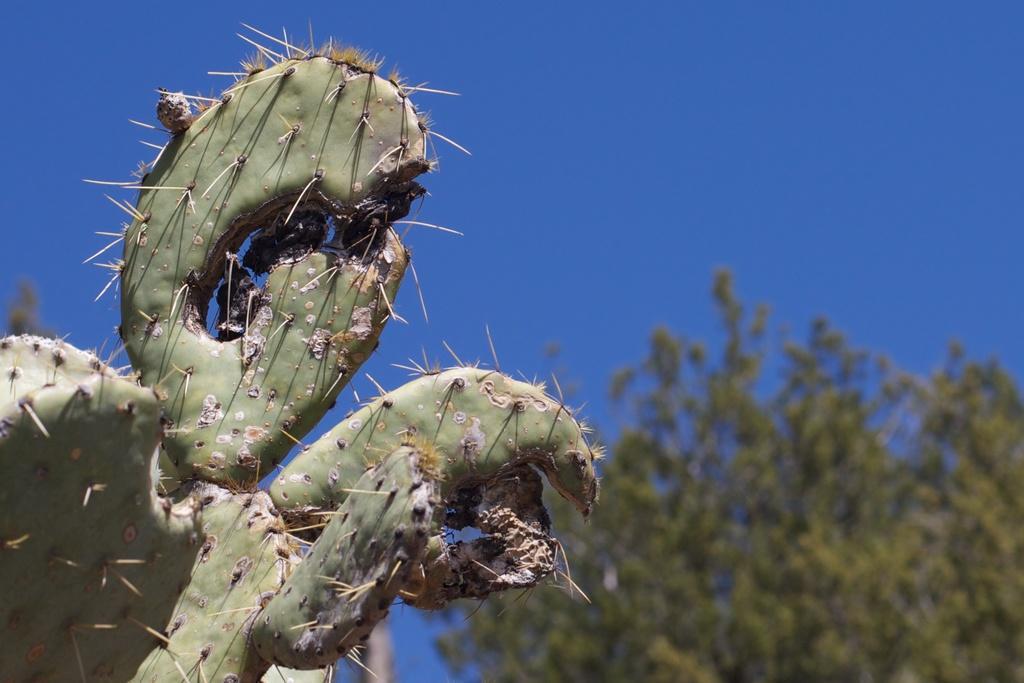Can you describe this image briefly? In this picture we can see a plant, trees and in the background we can see the sky. 